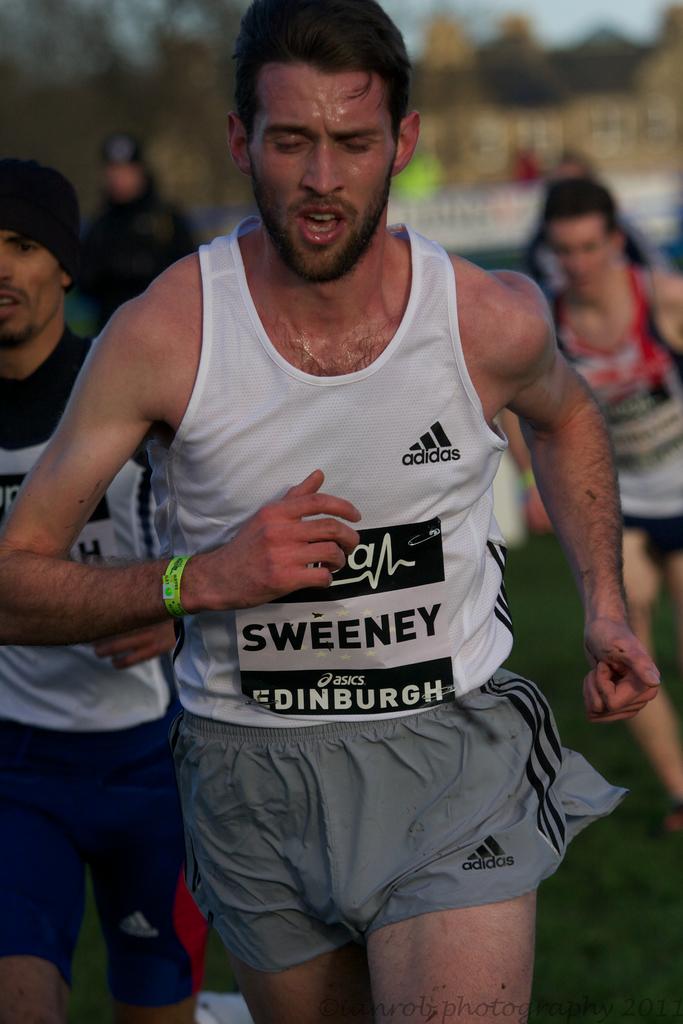Is that sweeney?
Keep it short and to the point. Yes. What brand name is on his tank and shorts?
Offer a very short reply. Adidas. 